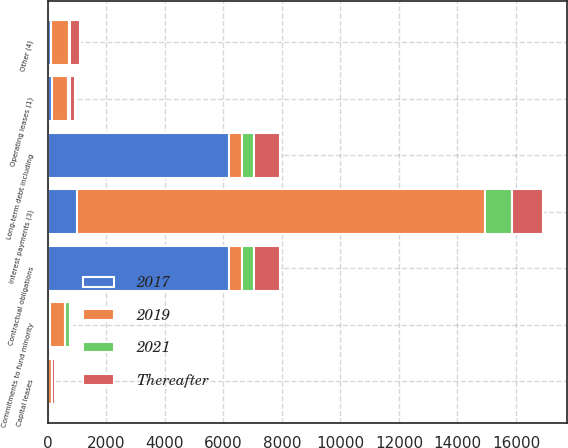<chart> <loc_0><loc_0><loc_500><loc_500><stacked_bar_chart><ecel><fcel>Operating leases (1)<fcel>Commitments to fund minority<fcel>Interest payments (3)<fcel>Other (4)<fcel>Contractual obligations<fcel>Long-term debt including<fcel>Capital leases<nl><fcel>2019<fcel>544<fcel>520<fcel>13925<fcel>603<fcel>464<fcel>464<fcel>132<nl><fcel>Thereafter<fcel>180<fcel>89<fcel>1058<fcel>351<fcel>887<fcel>887<fcel>106<nl><fcel>2017<fcel>130<fcel>72<fcel>1014<fcel>115<fcel>6188<fcel>6188<fcel>4<nl><fcel>2021<fcel>90<fcel>155<fcel>911<fcel>35<fcel>408<fcel>408<fcel>3<nl></chart> 